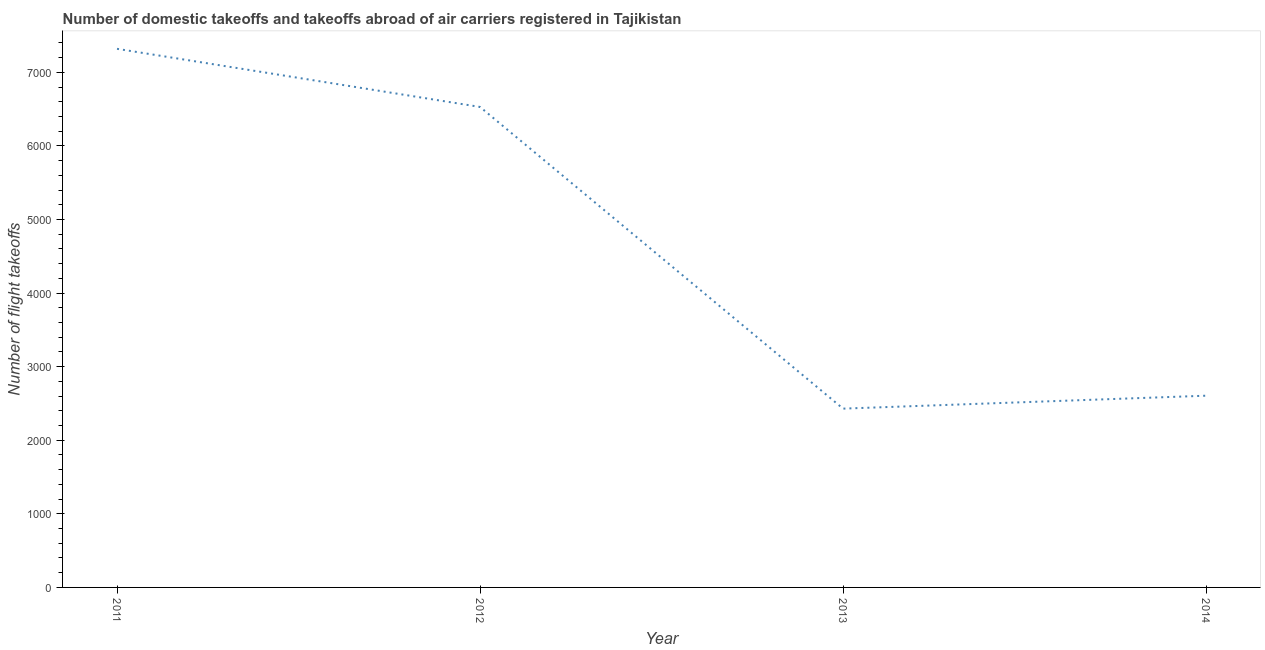What is the number of flight takeoffs in 2014?
Provide a succinct answer. 2605.73. Across all years, what is the maximum number of flight takeoffs?
Offer a terse response. 7320. Across all years, what is the minimum number of flight takeoffs?
Make the answer very short. 2430. In which year was the number of flight takeoffs maximum?
Keep it short and to the point. 2011. In which year was the number of flight takeoffs minimum?
Ensure brevity in your answer.  2013. What is the sum of the number of flight takeoffs?
Offer a very short reply. 1.89e+04. What is the difference between the number of flight takeoffs in 2012 and 2014?
Give a very brief answer. 3924.17. What is the average number of flight takeoffs per year?
Give a very brief answer. 4721.41. What is the median number of flight takeoffs?
Offer a very short reply. 4567.81. In how many years, is the number of flight takeoffs greater than 6000 ?
Provide a succinct answer. 2. What is the ratio of the number of flight takeoffs in 2011 to that in 2012?
Your answer should be very brief. 1.12. What is the difference between the highest and the second highest number of flight takeoffs?
Keep it short and to the point. 790.1. What is the difference between the highest and the lowest number of flight takeoffs?
Provide a succinct answer. 4890. How many lines are there?
Offer a very short reply. 1. How many years are there in the graph?
Offer a terse response. 4. What is the difference between two consecutive major ticks on the Y-axis?
Make the answer very short. 1000. Are the values on the major ticks of Y-axis written in scientific E-notation?
Provide a short and direct response. No. Does the graph contain any zero values?
Ensure brevity in your answer.  No. Does the graph contain grids?
Offer a very short reply. No. What is the title of the graph?
Ensure brevity in your answer.  Number of domestic takeoffs and takeoffs abroad of air carriers registered in Tajikistan. What is the label or title of the X-axis?
Your answer should be very brief. Year. What is the label or title of the Y-axis?
Your answer should be very brief. Number of flight takeoffs. What is the Number of flight takeoffs in 2011?
Offer a terse response. 7320. What is the Number of flight takeoffs of 2012?
Offer a very short reply. 6529.9. What is the Number of flight takeoffs of 2013?
Make the answer very short. 2430. What is the Number of flight takeoffs of 2014?
Your answer should be very brief. 2605.73. What is the difference between the Number of flight takeoffs in 2011 and 2012?
Ensure brevity in your answer.  790.1. What is the difference between the Number of flight takeoffs in 2011 and 2013?
Provide a succinct answer. 4890. What is the difference between the Number of flight takeoffs in 2011 and 2014?
Provide a short and direct response. 4714.27. What is the difference between the Number of flight takeoffs in 2012 and 2013?
Provide a short and direct response. 4099.9. What is the difference between the Number of flight takeoffs in 2012 and 2014?
Your answer should be very brief. 3924.17. What is the difference between the Number of flight takeoffs in 2013 and 2014?
Provide a succinct answer. -175.73. What is the ratio of the Number of flight takeoffs in 2011 to that in 2012?
Provide a succinct answer. 1.12. What is the ratio of the Number of flight takeoffs in 2011 to that in 2013?
Your response must be concise. 3.01. What is the ratio of the Number of flight takeoffs in 2011 to that in 2014?
Offer a very short reply. 2.81. What is the ratio of the Number of flight takeoffs in 2012 to that in 2013?
Your answer should be compact. 2.69. What is the ratio of the Number of flight takeoffs in 2012 to that in 2014?
Offer a terse response. 2.51. What is the ratio of the Number of flight takeoffs in 2013 to that in 2014?
Provide a short and direct response. 0.93. 